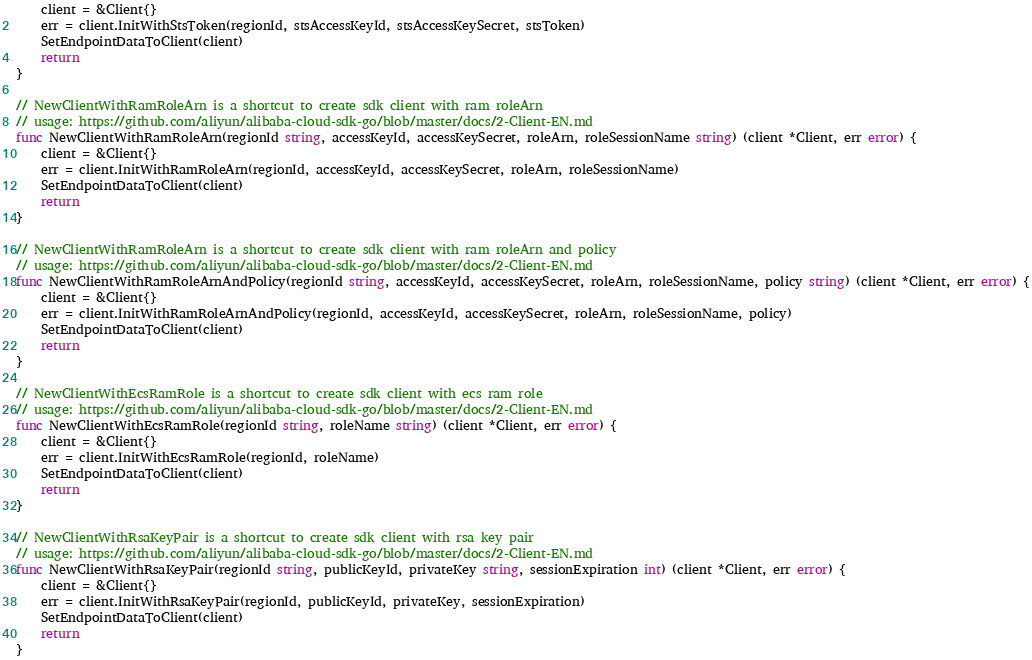<code> <loc_0><loc_0><loc_500><loc_500><_Go_>	client = &Client{}
	err = client.InitWithStsToken(regionId, stsAccessKeyId, stsAccessKeySecret, stsToken)
	SetEndpointDataToClient(client)
	return
}

// NewClientWithRamRoleArn is a shortcut to create sdk client with ram roleArn
// usage: https://github.com/aliyun/alibaba-cloud-sdk-go/blob/master/docs/2-Client-EN.md
func NewClientWithRamRoleArn(regionId string, accessKeyId, accessKeySecret, roleArn, roleSessionName string) (client *Client, err error) {
	client = &Client{}
	err = client.InitWithRamRoleArn(regionId, accessKeyId, accessKeySecret, roleArn, roleSessionName)
	SetEndpointDataToClient(client)
	return
}

// NewClientWithRamRoleArn is a shortcut to create sdk client with ram roleArn and policy
// usage: https://github.com/aliyun/alibaba-cloud-sdk-go/blob/master/docs/2-Client-EN.md
func NewClientWithRamRoleArnAndPolicy(regionId string, accessKeyId, accessKeySecret, roleArn, roleSessionName, policy string) (client *Client, err error) {
	client = &Client{}
	err = client.InitWithRamRoleArnAndPolicy(regionId, accessKeyId, accessKeySecret, roleArn, roleSessionName, policy)
	SetEndpointDataToClient(client)
	return
}

// NewClientWithEcsRamRole is a shortcut to create sdk client with ecs ram role
// usage: https://github.com/aliyun/alibaba-cloud-sdk-go/blob/master/docs/2-Client-EN.md
func NewClientWithEcsRamRole(regionId string, roleName string) (client *Client, err error) {
	client = &Client{}
	err = client.InitWithEcsRamRole(regionId, roleName)
	SetEndpointDataToClient(client)
	return
}

// NewClientWithRsaKeyPair is a shortcut to create sdk client with rsa key pair
// usage: https://github.com/aliyun/alibaba-cloud-sdk-go/blob/master/docs/2-Client-EN.md
func NewClientWithRsaKeyPair(regionId string, publicKeyId, privateKey string, sessionExpiration int) (client *Client, err error) {
	client = &Client{}
	err = client.InitWithRsaKeyPair(regionId, publicKeyId, privateKey, sessionExpiration)
	SetEndpointDataToClient(client)
	return
}
</code> 